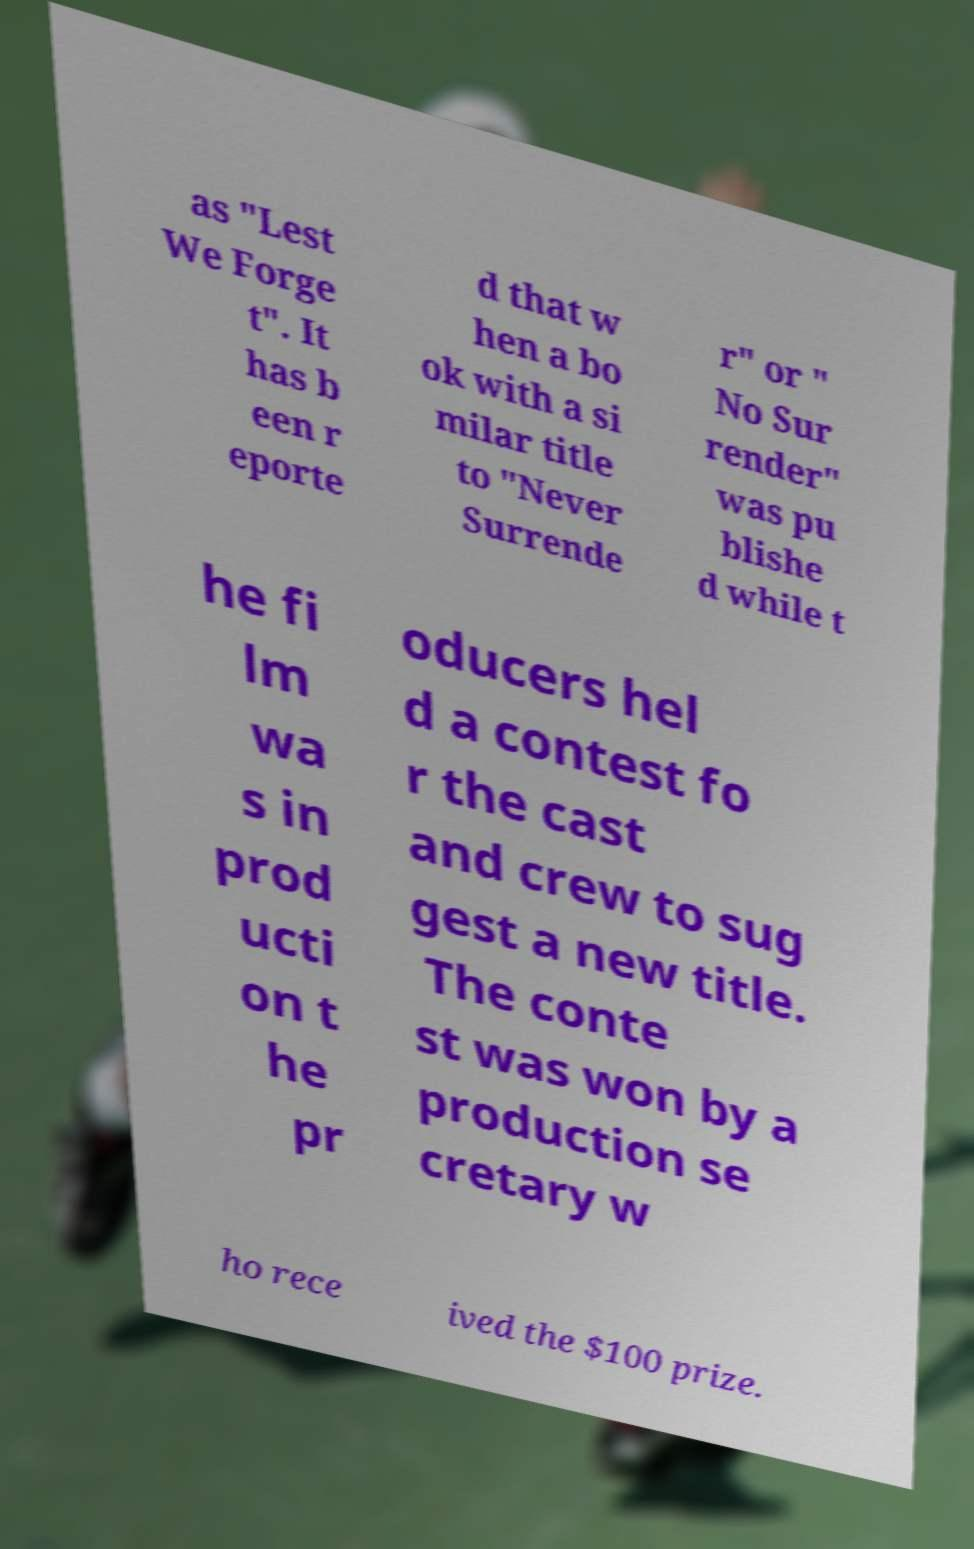I need the written content from this picture converted into text. Can you do that? as "Lest We Forge t". It has b een r eporte d that w hen a bo ok with a si milar title to "Never Surrende r" or " No Sur render" was pu blishe d while t he fi lm wa s in prod ucti on t he pr oducers hel d a contest fo r the cast and crew to sug gest a new title. The conte st was won by a production se cretary w ho rece ived the $100 prize. 